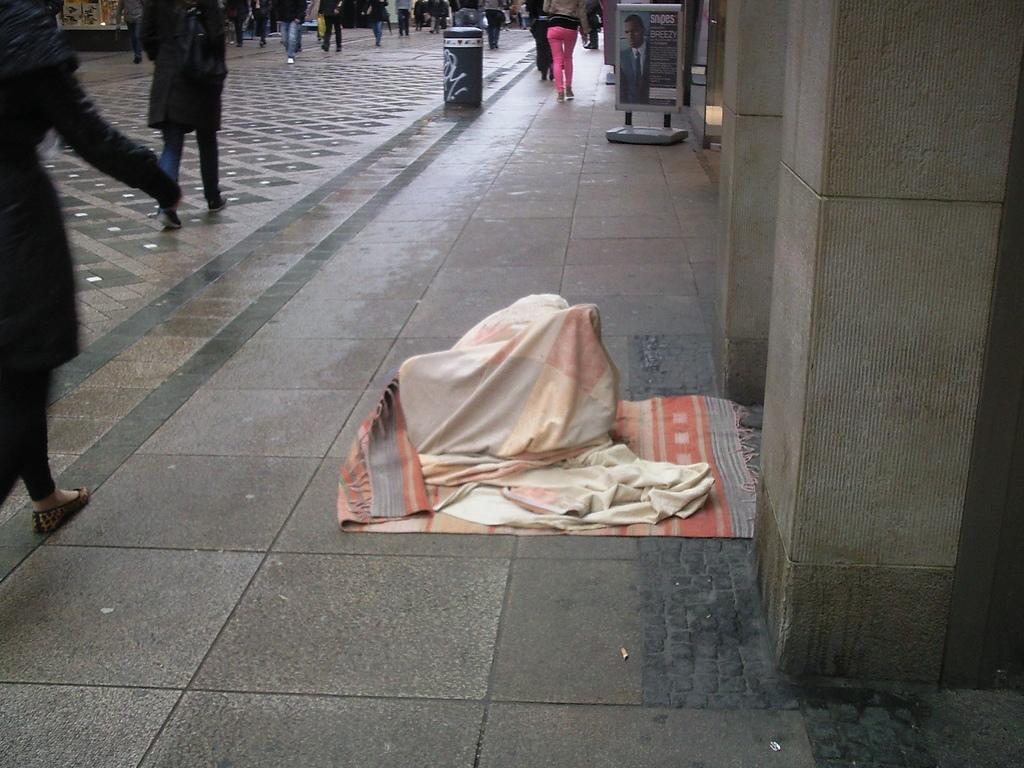Please provide a concise description of this image. Here we can see people, board and clothes. 